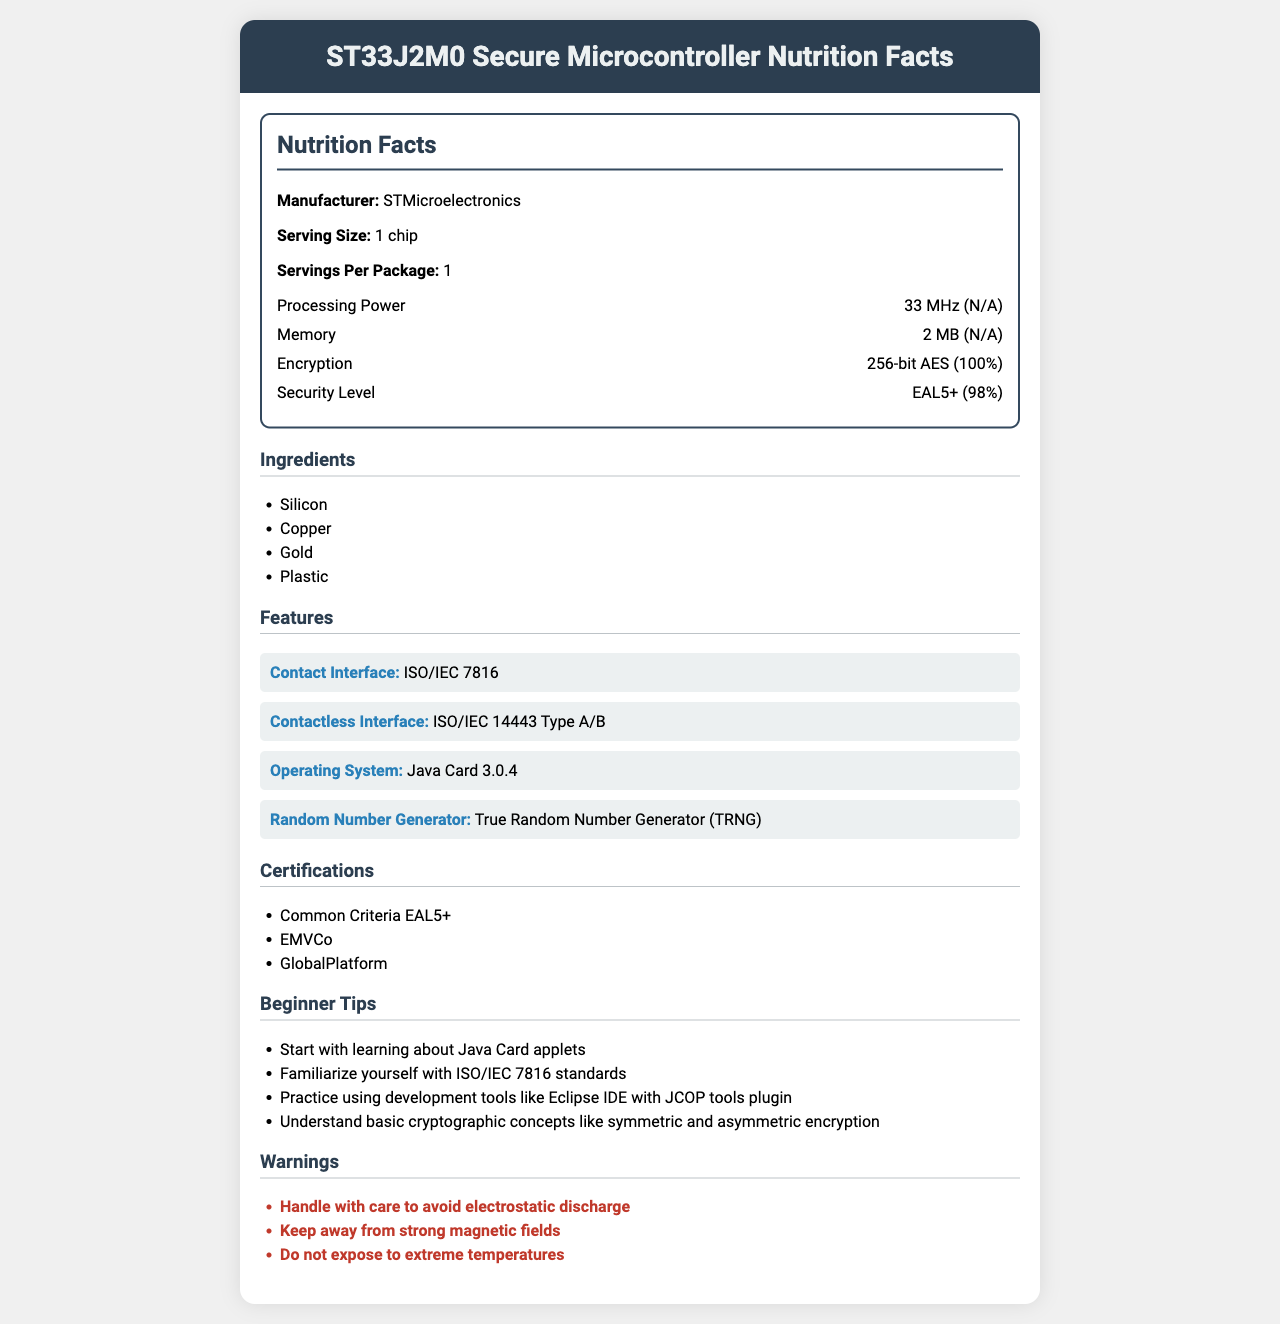what is the manufacturing company? The document states that the manufacturer of the ST33J2M0 Secure Microcontroller is STMicroelectronics.
Answer: STMicroelectronics what is the encryption capability of the chip? The document lists "256-bit AES" under the Nutrition Facts as the encryption capability of the chip.
Answer: 256-bit AES What is the processing power of the ST33J2M0 chip? According to the Nutrition Facts section, the processing power of the chip is 33 MHz.
Answer: 33 MHz What type of memory does the chip have and how much? The Nutrition Facts section states that the chip has 2 MB of memory.
Answer: 2 MB of memory What security level has been achieved by the chip? The Security Level in the Nutrition Facts section is listed as EAL5+.
Answer: EAL5+ Which interface type(s) does the chip support? A. Contact Interface B. Contactless Interface C. Both The Features section indicates that the chip supports both ISO/IEC 7816 (Contact Interface) and ISO/IEC 14443 Type A/B (Contactless Interface).
Answer: C. Both What operating system does the chip use? A. Windows B. Java Card 3.0.4 C. Linux The Features section specifies that the operating system on the chip is Java Card 3.0.4.
Answer: B. Java Card 3.0.4 Does the chip have a True Random Number Generator (TRNG)? The Features section lists a True Random Number Generator (TRNG) as one of the chip's features.
Answer: Yes Is the chip designed in such a way to be secure from electrostatic discharge? While the Warnings section advises to handle with care to avoid electrostatic discharge, it does not specify any design features or measures that ensure security from electrostatic discharge.
Answer: Not enough information What should you avoid exposing the chip to? The Warnings section advises keeping the chip away from strong magnetic fields and not exposing it to extreme temperatures.
Answer: Strong magnetic fields and extreme temperatures What certifications does the chip have? The Certifications section lists the chip as having certifications from Common Criteria EAL5+, EMVCo, and GlobalPlatform.
Answer: Common Criteria EAL5+, EMVCo, and GlobalPlatform Describe the main idea of the document. The document is formatted as a "Nutrition Facts" label and outlines various technical attributes such as processing power, memory, encryption capabilities, and security level. It also details the interfaces the chip supports, its operating system, and special features like a True Random Number Generator. Additionally, it offers some beginner tips for those new to the field and includes important handling warnings.
Answer: The document provides a detailed summary of the ST33J2M0 Secure Microcontroller's specifications, ingredients, features, certifications, beginner tips, and warnings. 